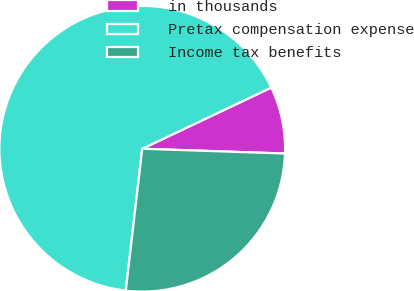<chart> <loc_0><loc_0><loc_500><loc_500><pie_chart><fcel>in thousands<fcel>Pretax compensation expense<fcel>Income tax benefits<nl><fcel>7.58%<fcel>66.12%<fcel>26.3%<nl></chart> 